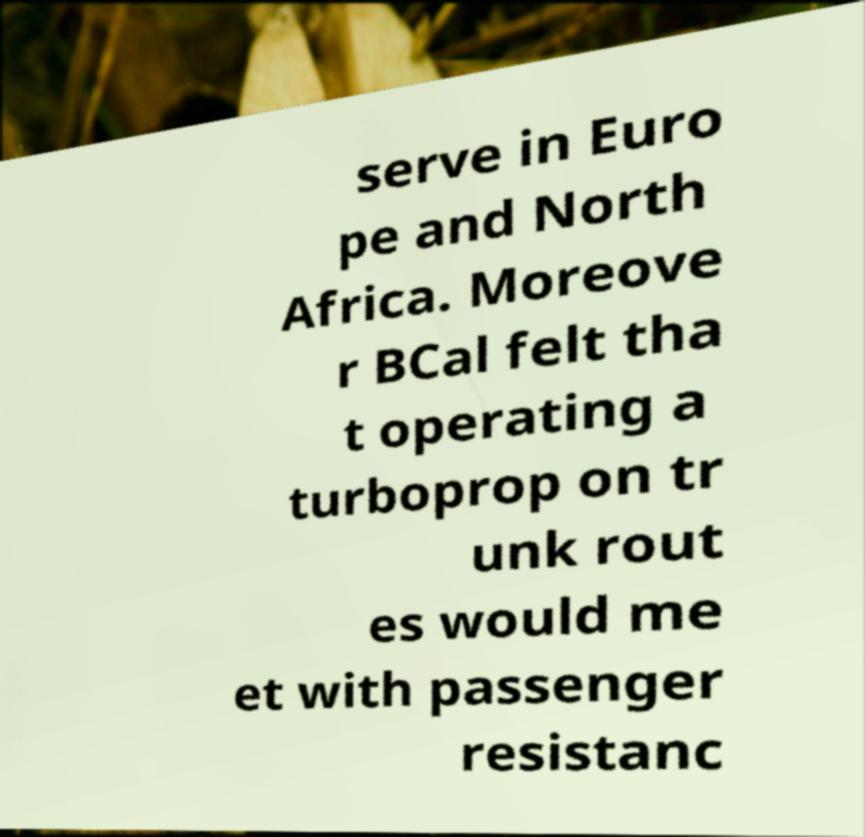Please read and relay the text visible in this image. What does it say? serve in Euro pe and North Africa. Moreove r BCal felt tha t operating a turboprop on tr unk rout es would me et with passenger resistanc 